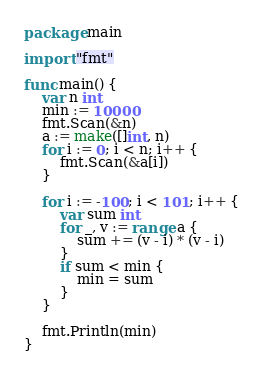<code> <loc_0><loc_0><loc_500><loc_500><_Go_>package main

import "fmt"

func main() {
	var n int
	min := 10000
	fmt.Scan(&n)
	a := make([]int, n)
	for i := 0; i < n; i++ {
		fmt.Scan(&a[i])
	}

	for i := -100; i < 101; i++ {
		var sum int
		for _, v := range a {
			sum += (v - i) * (v - i)
		}
		if sum < min {
			min = sum
		}
	}

	fmt.Println(min)
}</code> 